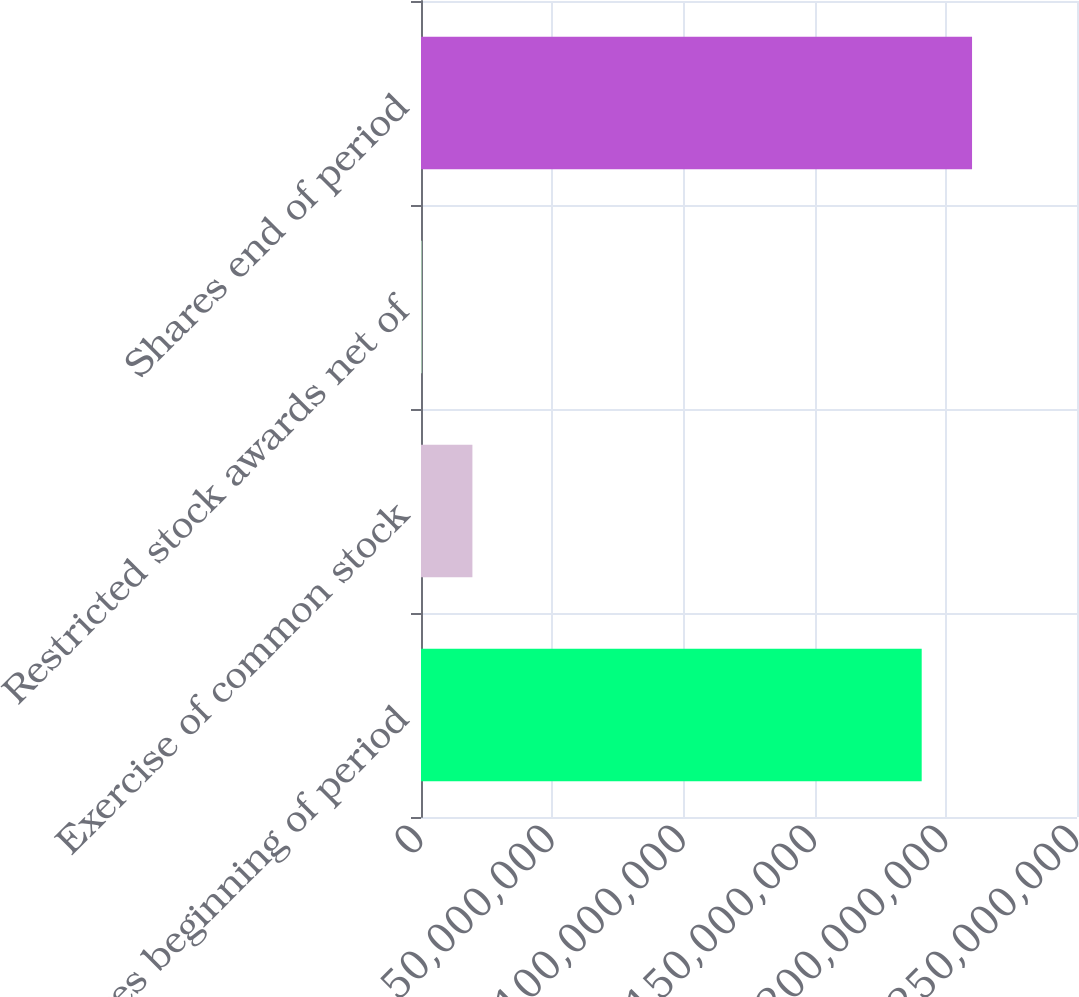<chart> <loc_0><loc_0><loc_500><loc_500><bar_chart><fcel>Shares beginning of period<fcel>Exercise of common stock<fcel>Restricted stock awards net of<fcel>Shares end of period<nl><fcel>1.90814e+08<fcel>1.95918e+07<fcel>402339<fcel>2.10004e+08<nl></chart> 